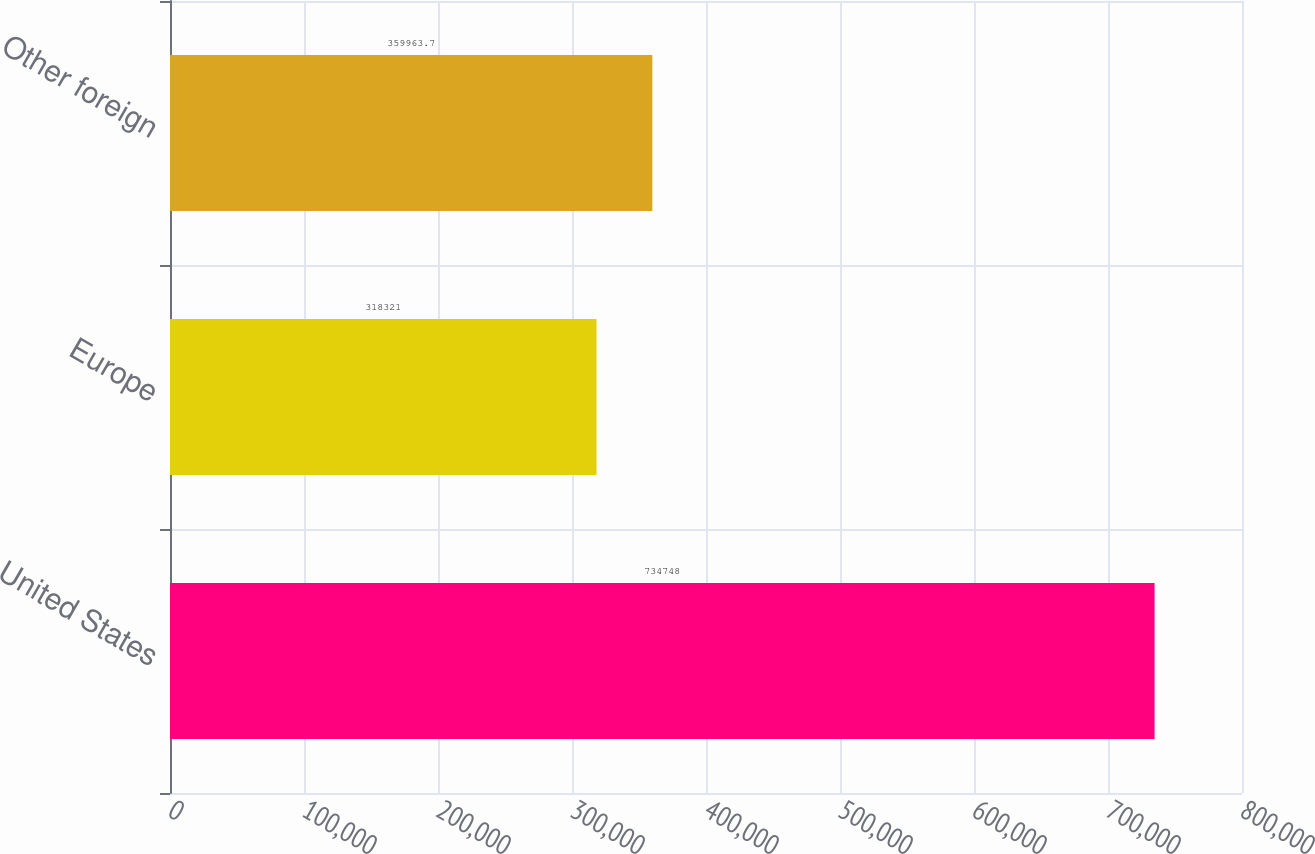Convert chart to OTSL. <chart><loc_0><loc_0><loc_500><loc_500><bar_chart><fcel>United States<fcel>Europe<fcel>Other foreign<nl><fcel>734748<fcel>318321<fcel>359964<nl></chart> 